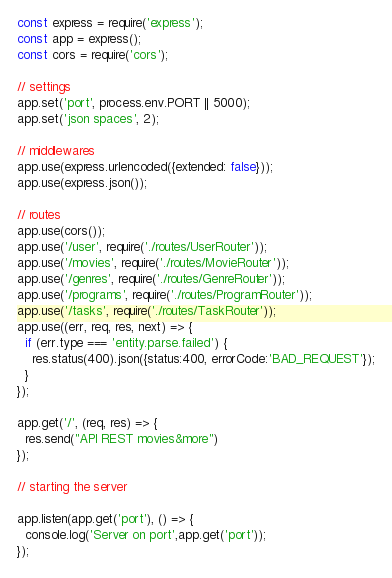Convert code to text. <code><loc_0><loc_0><loc_500><loc_500><_JavaScript_>const express = require('express');
const app = express();
const cors = require('cors');

// settings
app.set('port', process.env.PORT || 5000);
app.set('json spaces', 2);

// middlewares
app.use(express.urlencoded({extended: false}));
app.use(express.json());

// routes
app.use(cors());
app.use('/user', require('./routes/UserRouter'));
app.use('/movies', require('./routes/MovieRouter'));
app.use('/genres', require('./routes/GenreRouter'));
app.use('/programs', require('./routes/ProgramRouter'));
app.use('/tasks', require('./routes/TaskRouter'));
app.use((err, req, res, next) => {
  if (err.type === 'entity.parse.failed') {
    res.status(400).json({status:400, errorCode:'BAD_REQUEST'});
  }
});

app.get('/', (req, res) => {
  res.send("API REST movies&more")
});

// starting the server

app.listen(app.get('port'), () => {
  console.log('Server on port',app.get('port'));
});</code> 